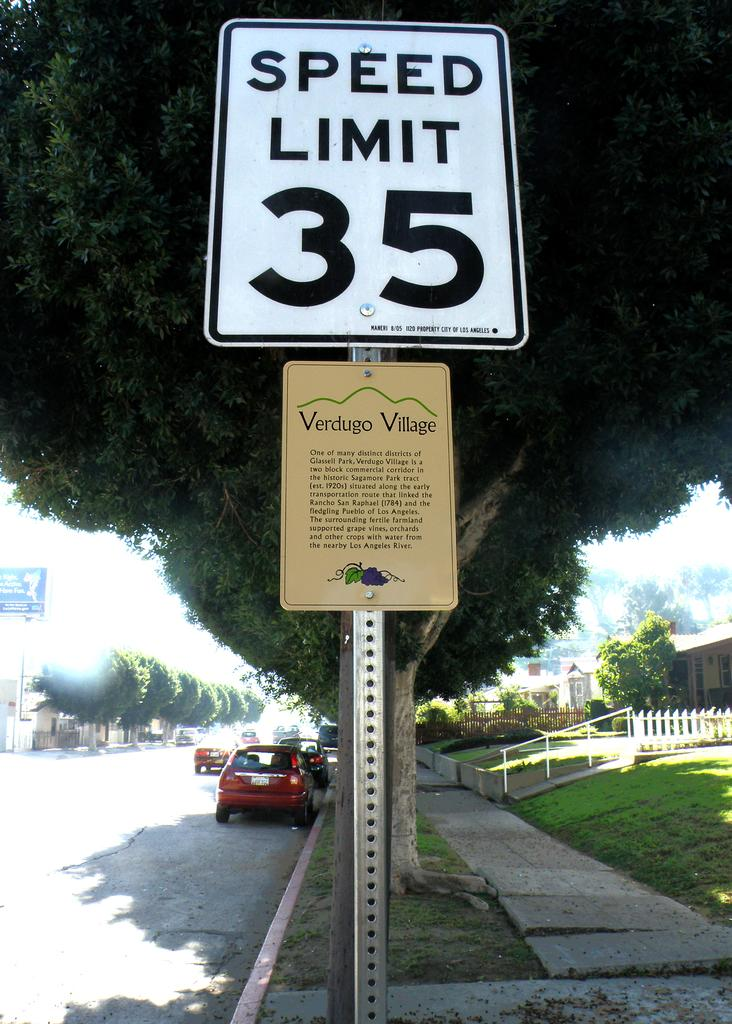<image>
Describe the image concisely. A sign that says Speed Limit 35 is on the side of a street lined with parked cars. 